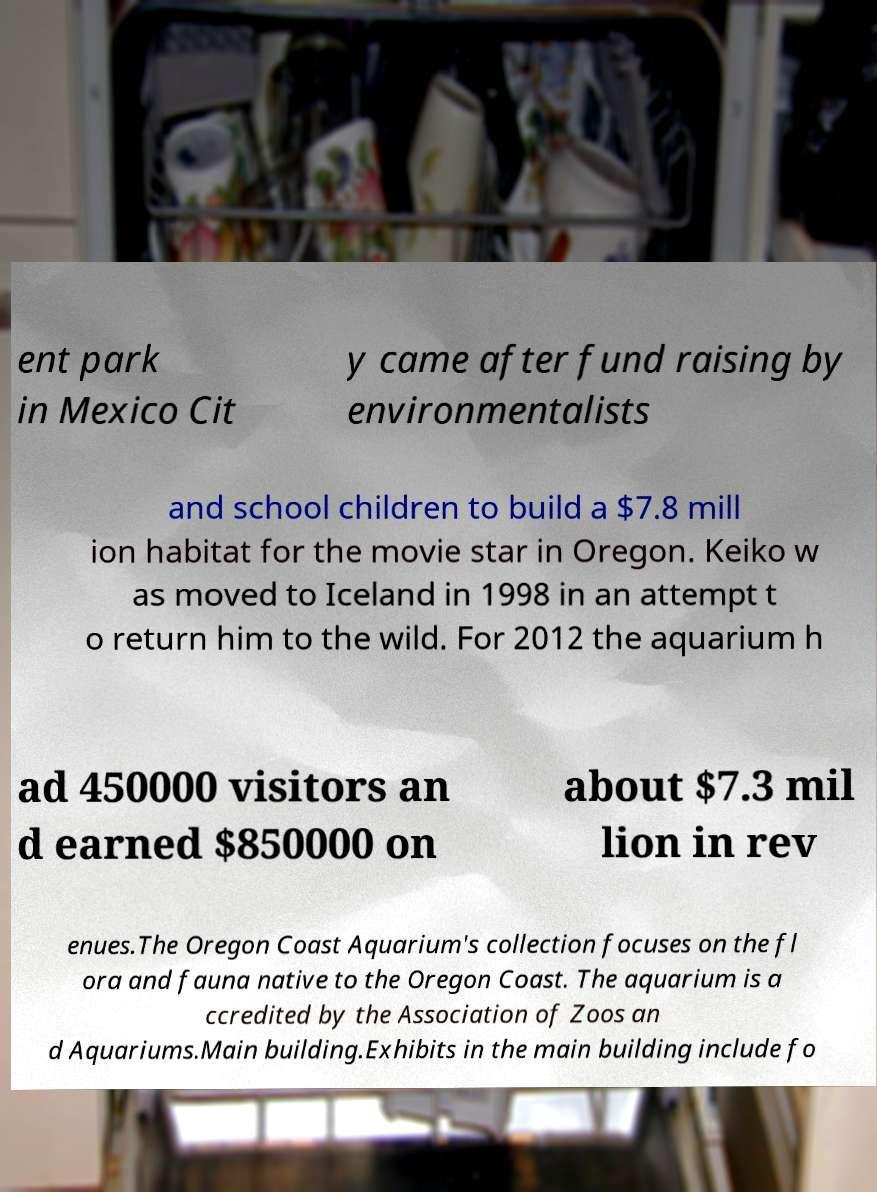For documentation purposes, I need the text within this image transcribed. Could you provide that? ent park in Mexico Cit y came after fund raising by environmentalists and school children to build a $7.8 mill ion habitat for the movie star in Oregon. Keiko w as moved to Iceland in 1998 in an attempt t o return him to the wild. For 2012 the aquarium h ad 450000 visitors an d earned $850000 on about $7.3 mil lion in rev enues.The Oregon Coast Aquarium's collection focuses on the fl ora and fauna native to the Oregon Coast. The aquarium is a ccredited by the Association of Zoos an d Aquariums.Main building.Exhibits in the main building include fo 